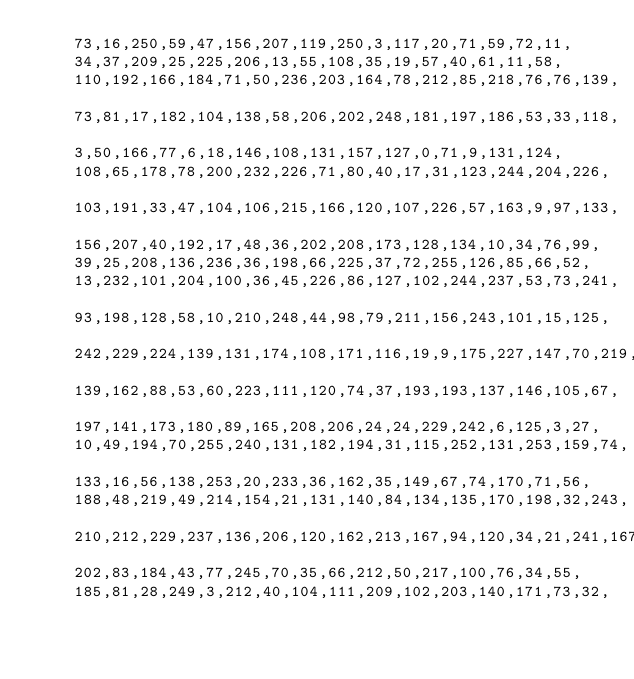<code> <loc_0><loc_0><loc_500><loc_500><_C++_>    73,16,250,59,47,156,207,119,250,3,117,20,71,59,72,11,
    34,37,209,25,225,206,13,55,108,35,19,57,40,61,11,58,
    110,192,166,184,71,50,236,203,164,78,212,85,218,76,76,139,
    73,81,17,182,104,138,58,206,202,248,181,197,186,53,33,118,
    3,50,166,77,6,18,146,108,131,157,127,0,71,9,131,124,
    108,65,178,78,200,232,226,71,80,40,17,31,123,244,204,226,
    103,191,33,47,104,106,215,166,120,107,226,57,163,9,97,133,
    156,207,40,192,17,48,36,202,208,173,128,134,10,34,76,99,
    39,25,208,136,236,36,198,66,225,37,72,255,126,85,66,52,
    13,232,101,204,100,36,45,226,86,127,102,244,237,53,73,241,
    93,198,128,58,10,210,248,44,98,79,211,156,243,101,15,125,
    242,229,224,139,131,174,108,171,116,19,9,175,227,147,70,219,
    139,162,88,53,60,223,111,120,74,37,193,193,137,146,105,67,
    197,141,173,180,89,165,208,206,24,24,229,242,6,125,3,27,
    10,49,194,70,255,240,131,182,194,31,115,252,131,253,159,74,
    133,16,56,138,253,20,233,36,162,35,149,67,74,170,71,56,
    188,48,219,49,214,154,21,131,140,84,134,135,170,198,32,243,
    210,212,229,237,136,206,120,162,213,167,94,120,34,21,241,167,
    202,83,184,43,77,245,70,35,66,212,50,217,100,76,34,55,
    185,81,28,249,3,212,40,104,111,209,102,203,140,171,73,32,</code> 